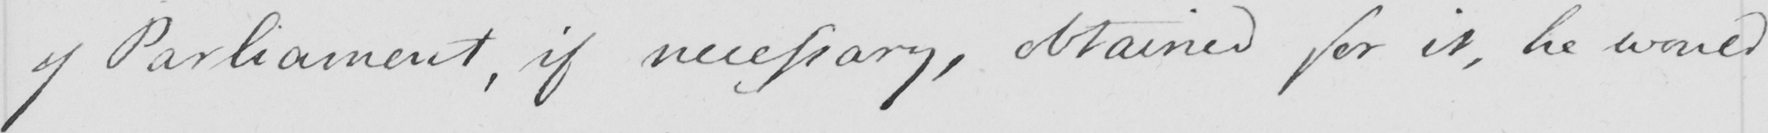What text is written in this handwritten line? of Parliament , if necessary , obtained for it , he would 